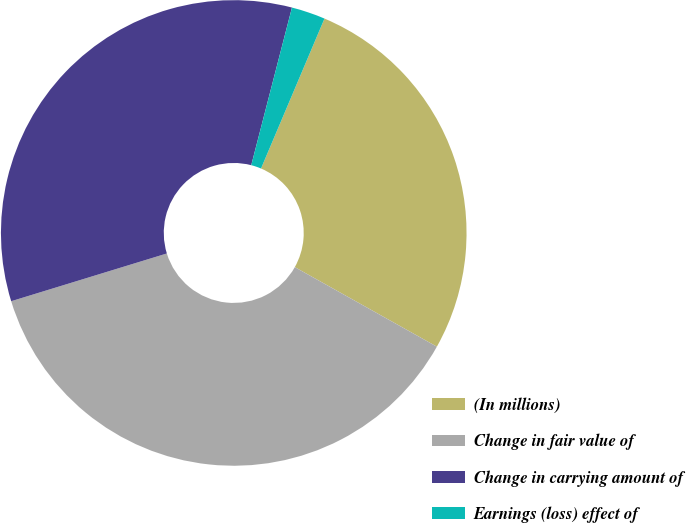Convert chart to OTSL. <chart><loc_0><loc_0><loc_500><loc_500><pie_chart><fcel>(In millions)<fcel>Change in fair value of<fcel>Change in carrying amount of<fcel>Earnings (loss) effect of<nl><fcel>26.75%<fcel>37.14%<fcel>33.76%<fcel>2.35%<nl></chart> 